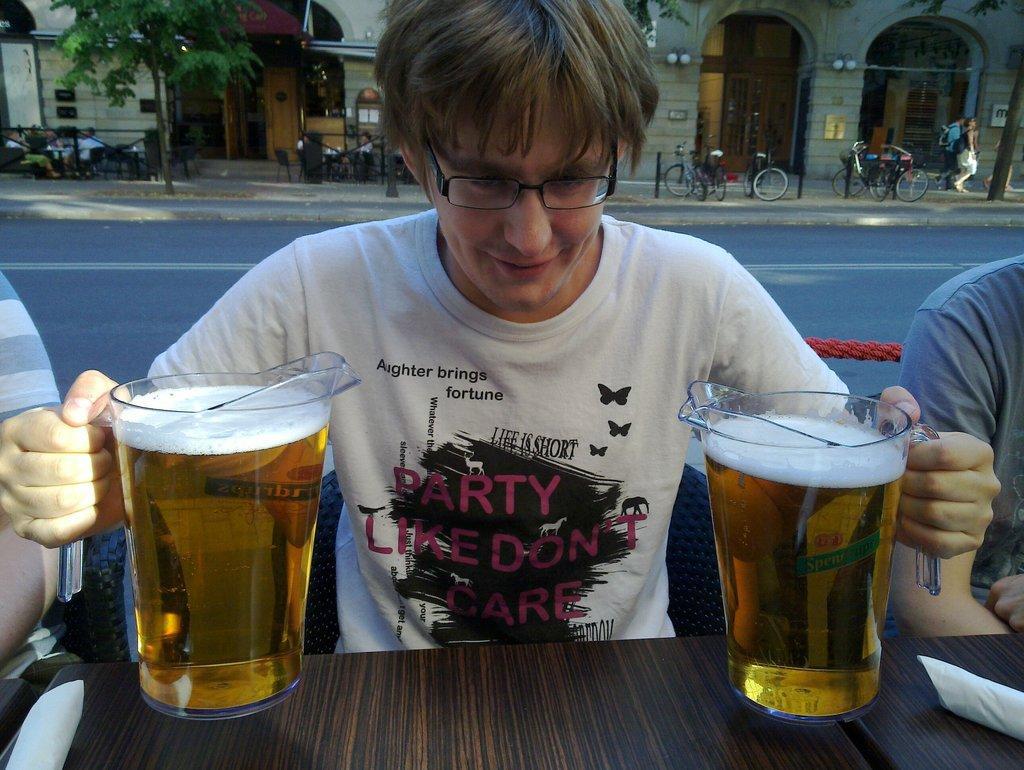Can you describe this image briefly? Here we can see a guy holding two glasses of beers which are kept on the table and behind him we can see bicycles, building and trees 